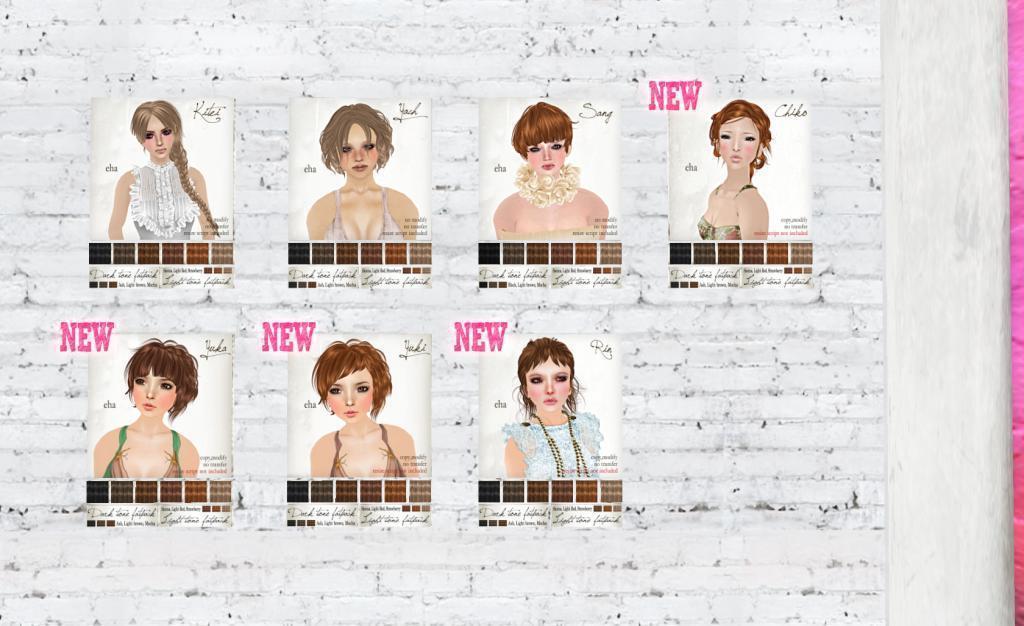Could you give a brief overview of what you see in this image? This is an animated image and there are seven posters on the wall and on the right there is a pillar. 